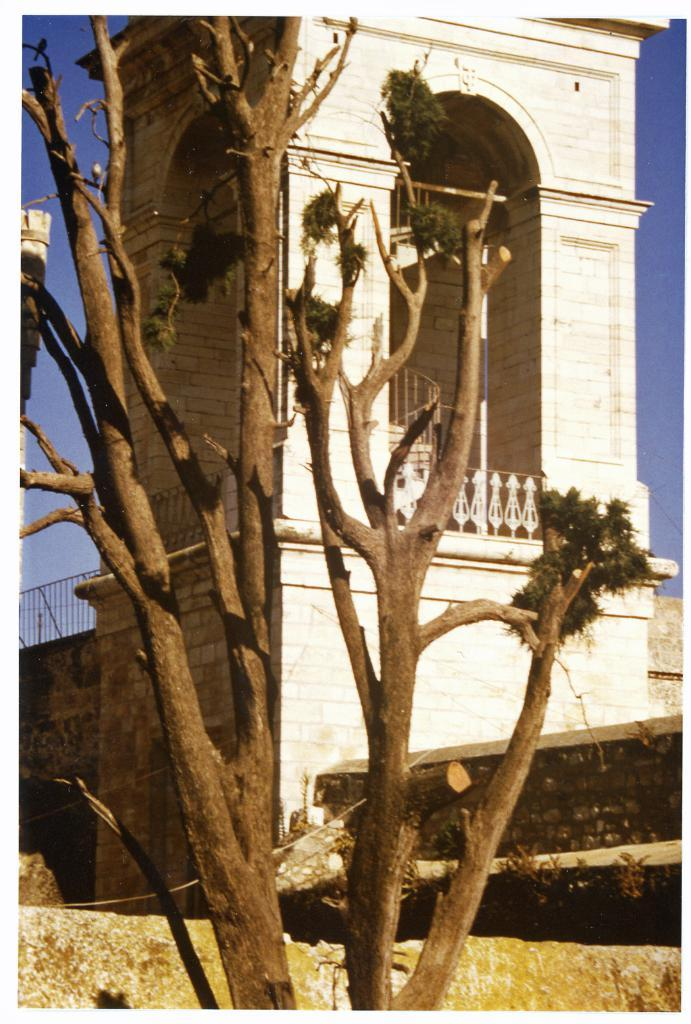What type of vegetation is present in the image? There are trees with branches and leaves in the image. What type of structure can be seen in the image? There appears to be a building in the image. Where are the scissors located in the image? There are no scissors present in the image. What type of line can be seen connecting the tree branches in the image? There is no line connecting the tree branches in the image; the branches are naturally connected to the tree trunks. 